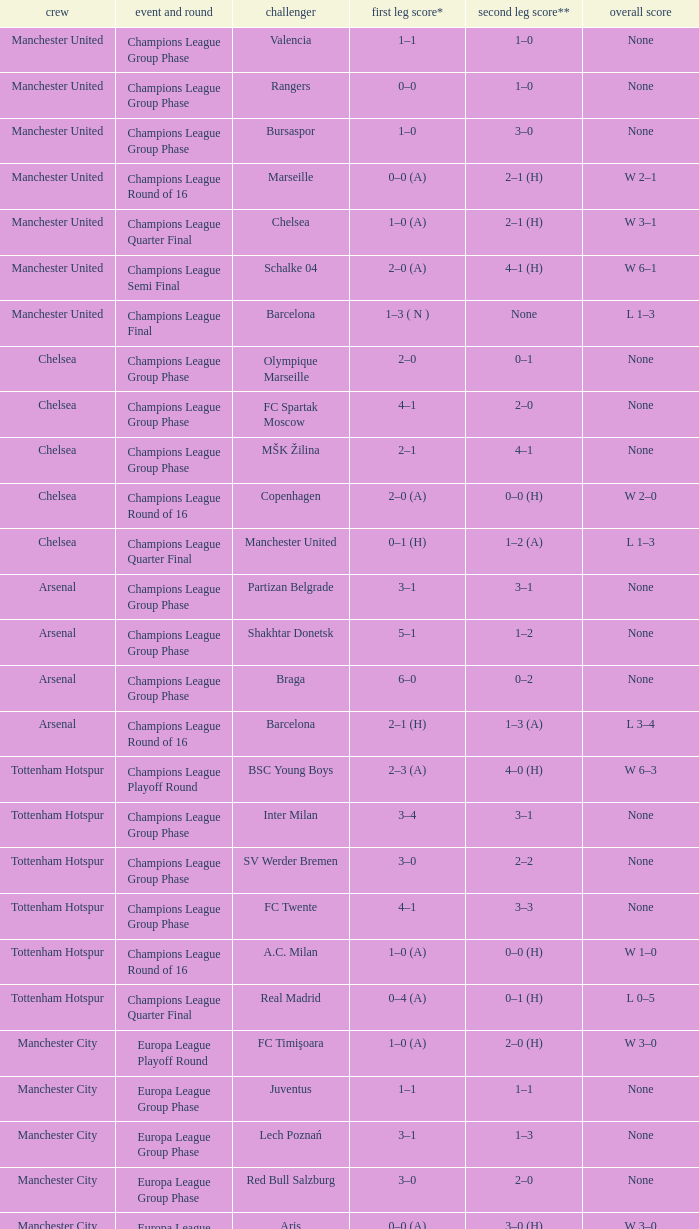How many goals did each team score in the first leg of the match between Liverpool and Steaua Bucureşti? 4–1. 